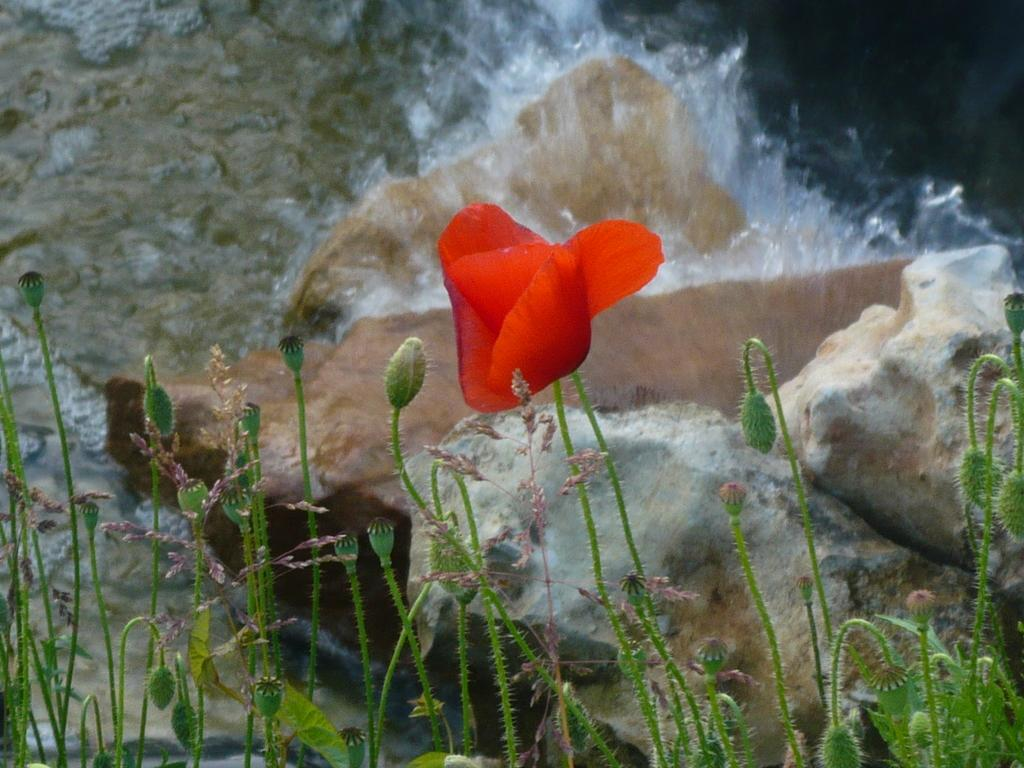What celestial bodies are depicted in the image? There are planets in the image. What is located in the front of the image? There is a flower in the front of the image. What can be seen in the background of the image? There is a stone and water visible in the background of the image. How many pies are being served by the writer in the image? There are no pies or writers present in the image. 